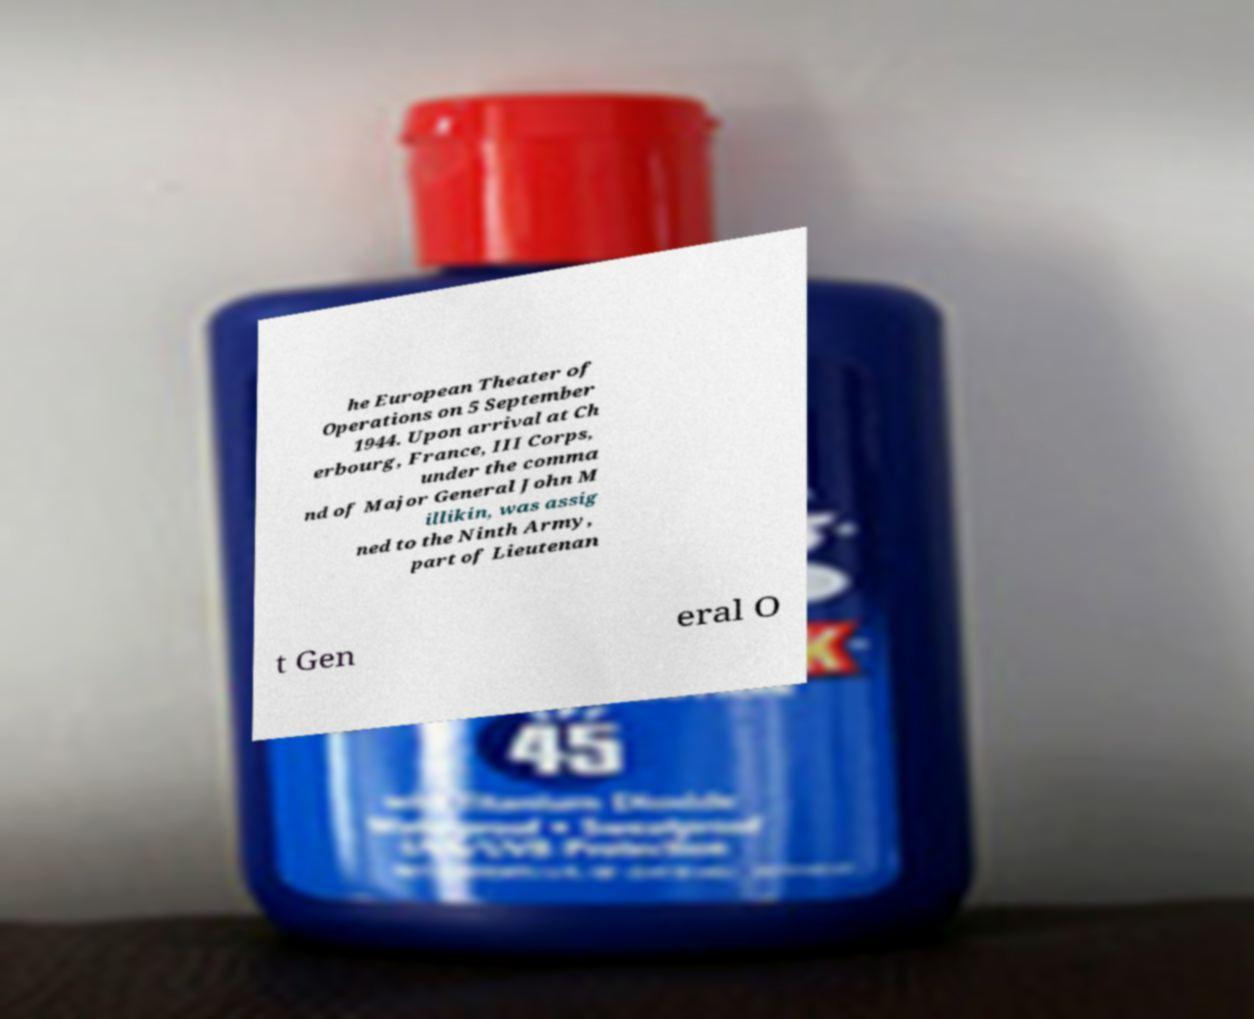For documentation purposes, I need the text within this image transcribed. Could you provide that? he European Theater of Operations on 5 September 1944. Upon arrival at Ch erbourg, France, III Corps, under the comma nd of Major General John M illikin, was assig ned to the Ninth Army, part of Lieutenan t Gen eral O 